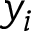<formula> <loc_0><loc_0><loc_500><loc_500>y _ { i }</formula> 